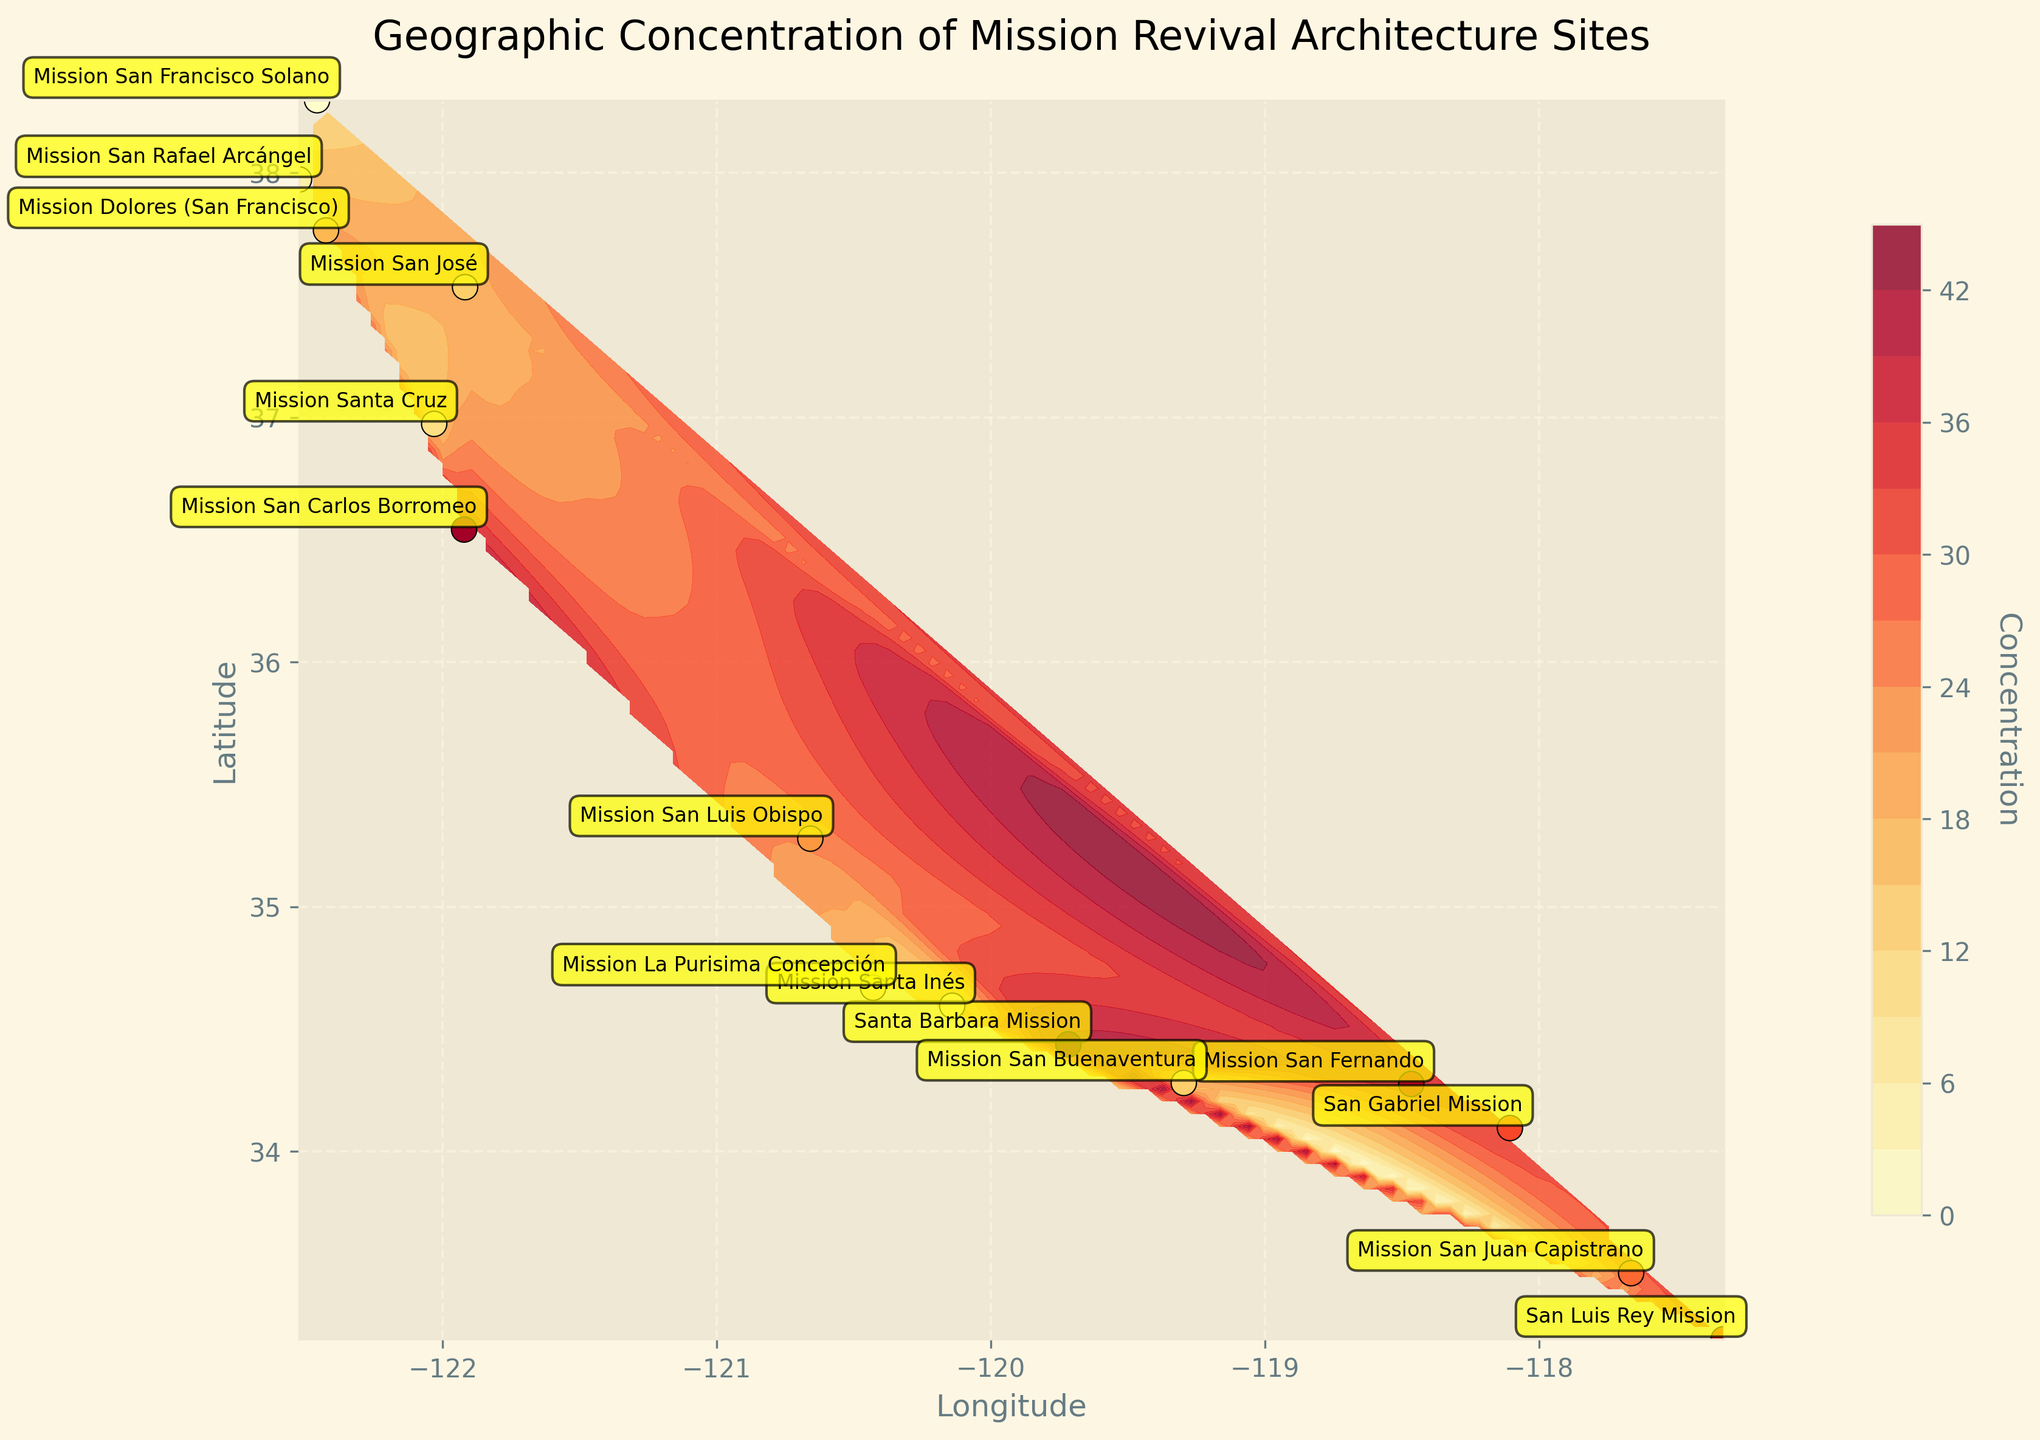What is the title of the plot? The title is located at the top of the plot and it summarizes the main subject of the figure, which is about the geographic concentration of Mission Revival Architecture sites.
Answer: Geographic Concentration of Mission Revival Architecture Sites How many Mission Revival Architecture sites are shown on the plot? The scatter points on the plot, each representing a site, can be counted to find the total number of sites.
Answer: 15 Which Mission Revival Architecture site has the highest concentration value? By identifying the site with the darkest color and checking the labels, we can determine the site with the highest concentration.
Answer: Santa Barbara Mission What is the concentration range depicted in the contour plot? The range can be observed from the color bar on the right side of the plot, which shows the minimum and maximum concentration values.
Answer: 12 to 40 Which site is located most to the southwest? By examining the positions on the x (Longitude) and y (Latitude) axes, the site with the lowest longitude and latitude is the most southwest.
Answer: San Luis Rey Mission Compare the concentration values of Mission San Fernando and San Luis Rey Mission. Which one is higher? Locate the two sites on the plot and compare their respective concentration values from the color gradation or numeric labels.
Answer: Mission San Fernando Identify the site located at the highest latitude. What is its concentration value? Check the site located at the uppermost position on the y-axis and read its concentration value from the scatter point color or annotation.
Answer: Mission San Francisco Solano, 12 Which sites are within the central California region (having latitude between 34° and 36°)? The sites that fall within this latitude range can be visually identified and listed.
Answer: Mission San Fernando, Mission Buenaventura, Santa Ines, Mission La Purisima Concepcion, Mission San Luis Obispo, Mission San Carlos Borromeo What is the average concentration value of all sites? Sum all concentration values and divide by the total number of sites: (30 + 35 + 28 + 40 + 25 + 38 + 18 + 20 + 22 + 15 + 12 + 32 + 16 + 18 + 20) / 15 = 349 / 15.
Answer: 23.27 Is there a noticeable pattern or trend in the geographic distribution of the sites? Observe the contour lines and scatter points to discuss any visible clustering or spread across the state.
Answer: Sites are clustered along the coast from south to north with higher concentrations in the south and central regions 